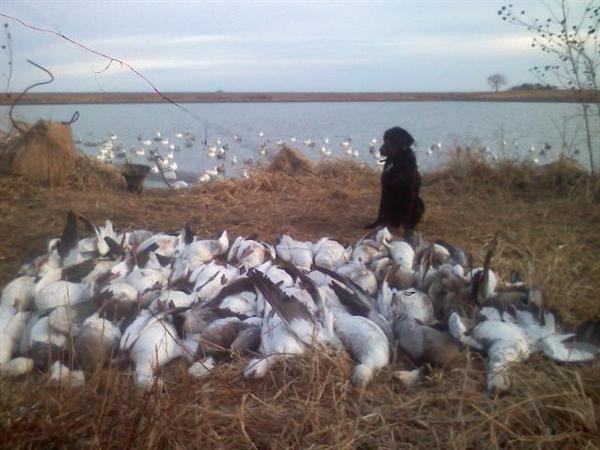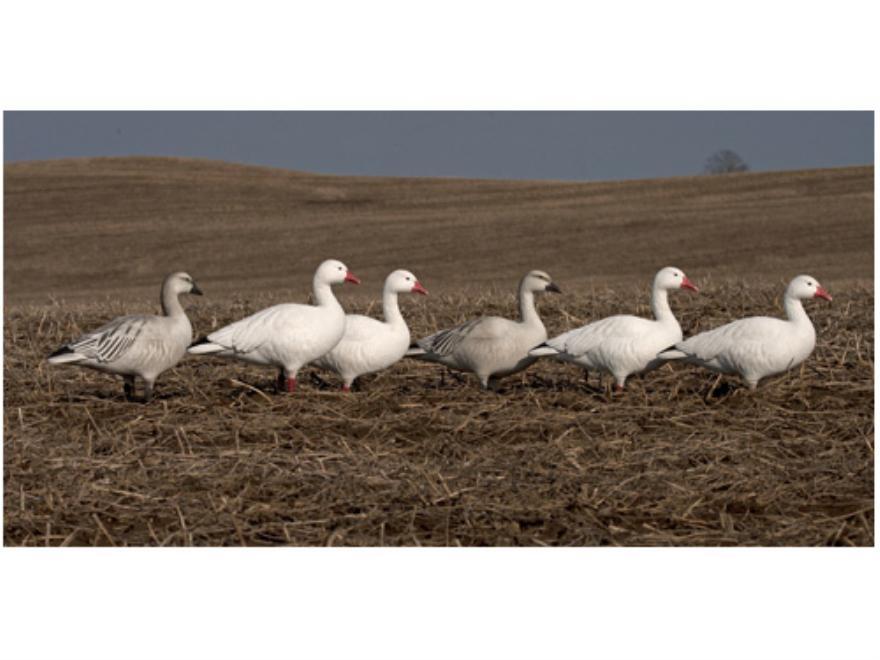The first image is the image on the left, the second image is the image on the right. Examine the images to the left and right. Is the description "Has atleast one picture with 6 or less ducks." accurate? Answer yes or no. Yes. The first image is the image on the left, the second image is the image on the right. Analyze the images presented: Is the assertion "Duck decoys, including white duck forms with heads bent down, are in a field of yellow straw in one image." valid? Answer yes or no. No. 